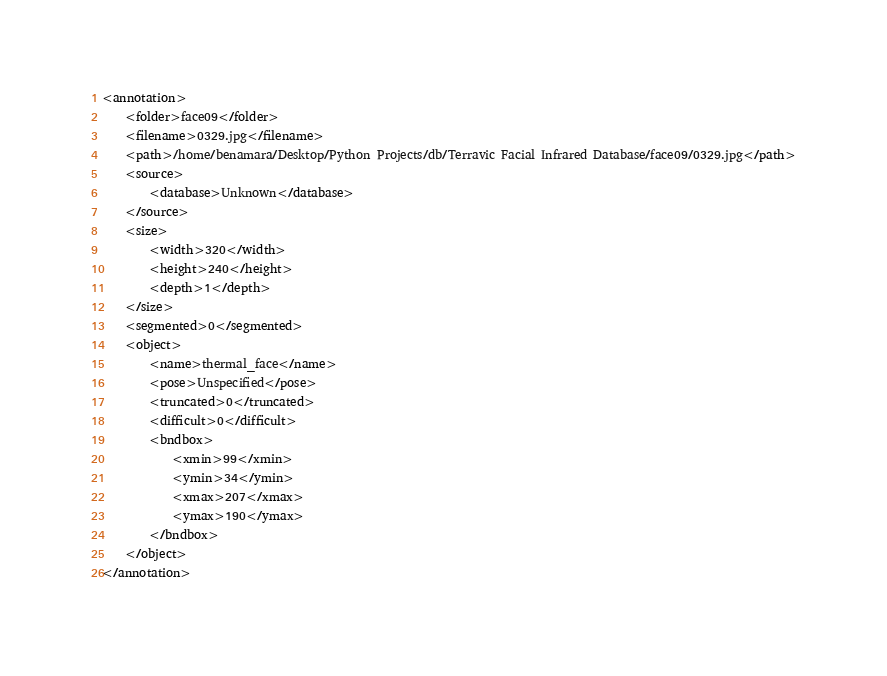<code> <loc_0><loc_0><loc_500><loc_500><_XML_><annotation>
	<folder>face09</folder>
	<filename>0329.jpg</filename>
	<path>/home/benamara/Desktop/Python Projects/db/Terravic Facial Infrared Database/face09/0329.jpg</path>
	<source>
		<database>Unknown</database>
	</source>
	<size>
		<width>320</width>
		<height>240</height>
		<depth>1</depth>
	</size>
	<segmented>0</segmented>
	<object>
		<name>thermal_face</name>
		<pose>Unspecified</pose>
		<truncated>0</truncated>
		<difficult>0</difficult>
		<bndbox>
			<xmin>99</xmin>
			<ymin>34</ymin>
			<xmax>207</xmax>
			<ymax>190</ymax>
		</bndbox>
	</object>
</annotation>
</code> 